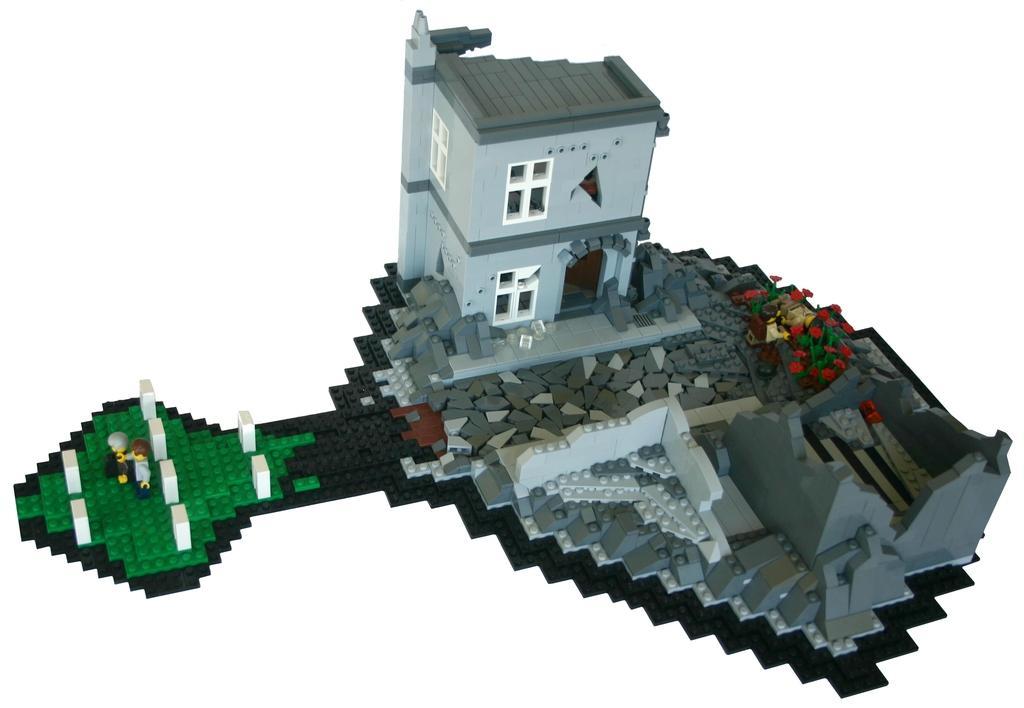Describe this image in one or two sentences. In the center of the image there is a depiction of a building. 